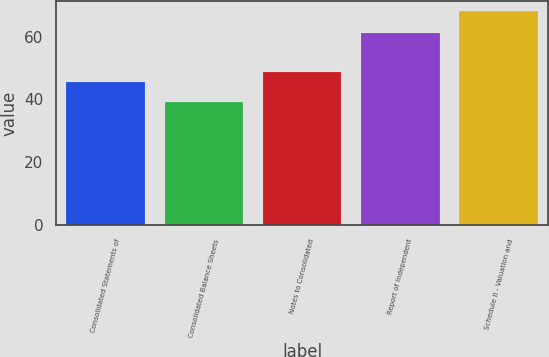<chart> <loc_0><loc_0><loc_500><loc_500><bar_chart><fcel>Consolidated Statements of<fcel>Consolidated Balance Sheets<fcel>Notes to Consolidated<fcel>Report of Independent<fcel>Schedule II - Valuation and<nl><fcel>45.6<fcel>39.2<fcel>48.8<fcel>61<fcel>68<nl></chart> 